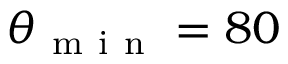Convert formula to latex. <formula><loc_0><loc_0><loc_500><loc_500>\theta _ { m i n } = 8 0</formula> 